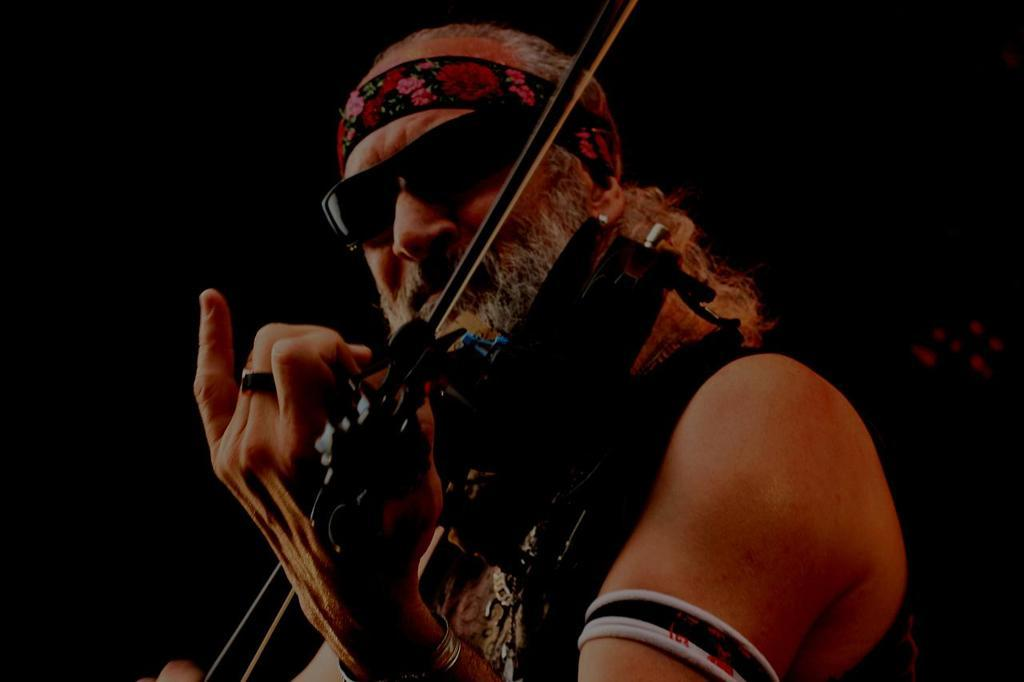What is the man in the image doing? The man is playing a violin in the image. What accessories is the man wearing on his head? The man is wearing a headband and goggles in the image. What type of jewelry is the man wearing on his hand? The man has a ring and a bangle on his hand in the image. How many pies can be seen on the table in the image? There are no pies present in the image; it features a man playing a violin. What type of animal is laughing in the image? There is no animal or laughter present in the image. 